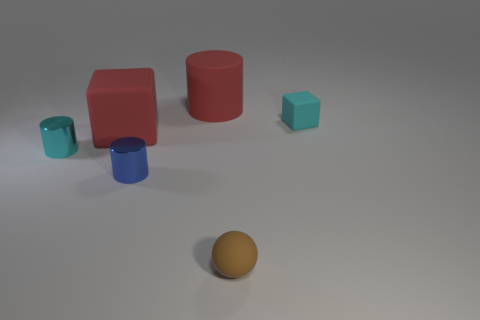There is a cube that is in front of the small matte block; what is its size?
Your answer should be compact. Large. What material is the cyan cylinder?
Provide a succinct answer. Metal. There is a big red matte object that is right of the big red rubber object to the left of the matte cylinder; what is its shape?
Make the answer very short. Cylinder. What number of other objects are there of the same shape as the brown matte thing?
Make the answer very short. 0. There is a cyan matte object; are there any rubber spheres in front of it?
Your response must be concise. Yes. The ball has what color?
Offer a terse response. Brown. There is a rubber cylinder; is it the same color as the large object in front of the large red matte cylinder?
Your answer should be compact. Yes. Is there a blue thing of the same size as the cyan cylinder?
Your answer should be very brief. Yes. There is a rubber thing that is the same color as the matte cylinder; what size is it?
Ensure brevity in your answer.  Large. What is the material of the cyan thing on the left side of the tiny cyan matte block?
Offer a terse response. Metal. 